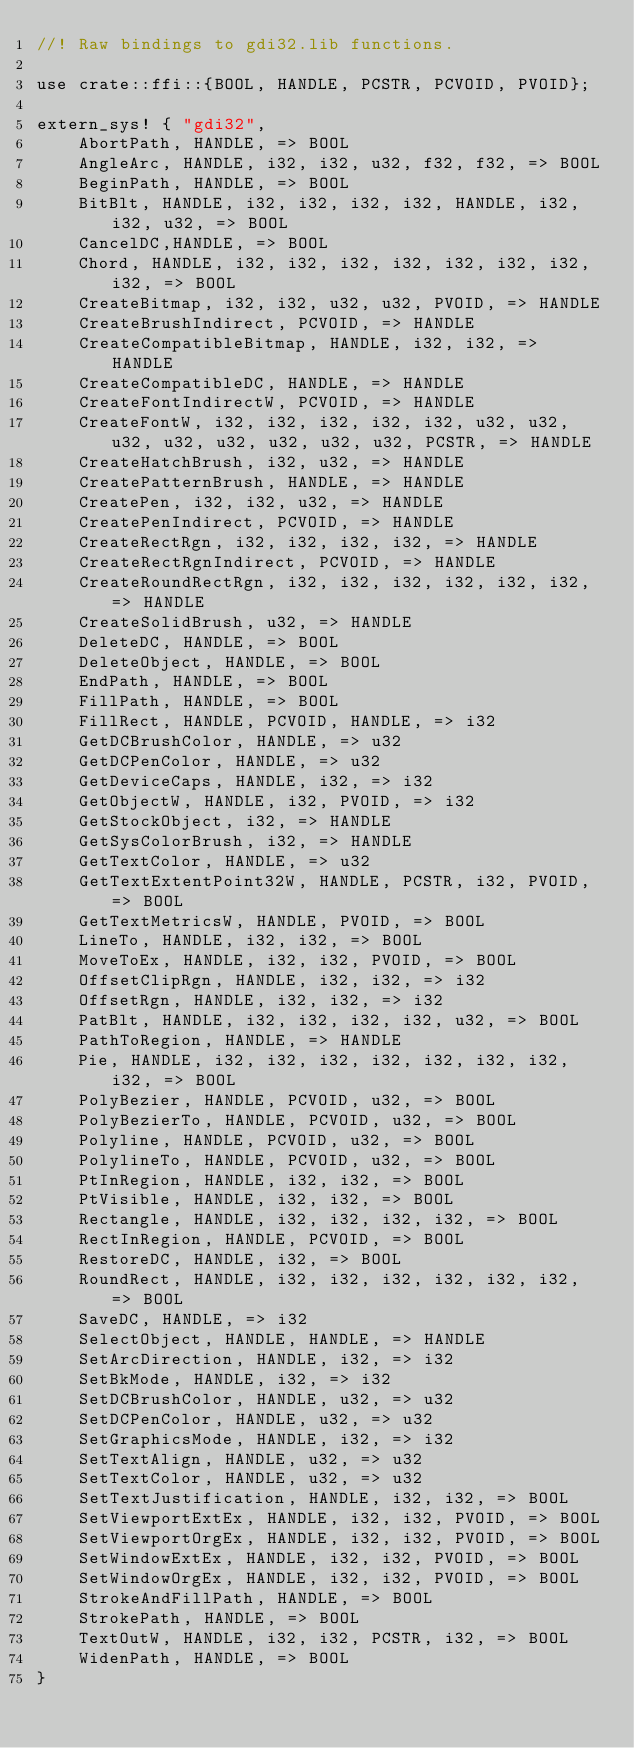Convert code to text. <code><loc_0><loc_0><loc_500><loc_500><_Rust_>//! Raw bindings to gdi32.lib functions.

use crate::ffi::{BOOL, HANDLE, PCSTR, PCVOID, PVOID};

extern_sys! { "gdi32",
	AbortPath, HANDLE, => BOOL
	AngleArc, HANDLE, i32, i32, u32, f32, f32, => BOOL
	BeginPath, HANDLE, => BOOL
	BitBlt, HANDLE, i32, i32, i32, i32, HANDLE, i32, i32, u32, => BOOL
	CancelDC,HANDLE, => BOOL
	Chord, HANDLE, i32, i32, i32, i32, i32, i32, i32, i32, => BOOL
	CreateBitmap, i32, i32, u32, u32, PVOID, => HANDLE
	CreateBrushIndirect, PCVOID, => HANDLE
	CreateCompatibleBitmap, HANDLE, i32, i32, => HANDLE
	CreateCompatibleDC, HANDLE, => HANDLE
	CreateFontIndirectW, PCVOID, => HANDLE
	CreateFontW, i32, i32, i32, i32, i32, u32, u32, u32, u32, u32, u32, u32, u32, PCSTR, => HANDLE
	CreateHatchBrush, i32, u32, => HANDLE
	CreatePatternBrush, HANDLE, => HANDLE
	CreatePen, i32, i32, u32, => HANDLE
	CreatePenIndirect, PCVOID, => HANDLE
	CreateRectRgn, i32, i32, i32, i32, => HANDLE
	CreateRectRgnIndirect, PCVOID, => HANDLE
	CreateRoundRectRgn, i32, i32, i32, i32, i32, i32, => HANDLE
	CreateSolidBrush, u32, => HANDLE
	DeleteDC, HANDLE, => BOOL
	DeleteObject, HANDLE, => BOOL
	EndPath, HANDLE, => BOOL
	FillPath, HANDLE, => BOOL
	FillRect, HANDLE, PCVOID, HANDLE, => i32
	GetDCBrushColor, HANDLE, => u32
	GetDCPenColor, HANDLE, => u32
	GetDeviceCaps, HANDLE, i32, => i32
	GetObjectW, HANDLE, i32, PVOID, => i32
	GetStockObject, i32, => HANDLE
	GetSysColorBrush, i32, => HANDLE
	GetTextColor, HANDLE, => u32
	GetTextExtentPoint32W, HANDLE, PCSTR, i32, PVOID, => BOOL
	GetTextMetricsW, HANDLE, PVOID, => BOOL
	LineTo, HANDLE, i32, i32, => BOOL
	MoveToEx, HANDLE, i32, i32, PVOID, => BOOL
	OffsetClipRgn, HANDLE, i32, i32, => i32
	OffsetRgn, HANDLE, i32, i32, => i32
	PatBlt, HANDLE, i32, i32, i32, i32, u32, => BOOL
	PathToRegion, HANDLE, => HANDLE
	Pie, HANDLE, i32, i32, i32, i32, i32, i32, i32, i32, => BOOL
	PolyBezier, HANDLE, PCVOID, u32, => BOOL
	PolyBezierTo, HANDLE, PCVOID, u32, => BOOL
	Polyline, HANDLE, PCVOID, u32, => BOOL
	PolylineTo, HANDLE, PCVOID, u32, => BOOL
	PtInRegion, HANDLE, i32, i32, => BOOL
	PtVisible, HANDLE, i32, i32, => BOOL
	Rectangle, HANDLE, i32, i32, i32, i32, => BOOL
	RectInRegion, HANDLE, PCVOID, => BOOL
	RestoreDC, HANDLE, i32, => BOOL
	RoundRect, HANDLE, i32, i32, i32, i32, i32, i32, => BOOL
	SaveDC, HANDLE, => i32
	SelectObject, HANDLE, HANDLE, => HANDLE
	SetArcDirection, HANDLE, i32, => i32
	SetBkMode, HANDLE, i32, => i32
	SetDCBrushColor, HANDLE, u32, => u32
	SetDCPenColor, HANDLE, u32, => u32
	SetGraphicsMode, HANDLE, i32, => i32
	SetTextAlign, HANDLE, u32, => u32
	SetTextColor, HANDLE, u32, => u32
	SetTextJustification, HANDLE, i32, i32, => BOOL
	SetViewportExtEx, HANDLE, i32, i32, PVOID, => BOOL
	SetViewportOrgEx, HANDLE, i32, i32, PVOID, => BOOL
	SetWindowExtEx, HANDLE, i32, i32, PVOID, => BOOL
	SetWindowOrgEx, HANDLE, i32, i32, PVOID, => BOOL
	StrokeAndFillPath, HANDLE, => BOOL
	StrokePath, HANDLE, => BOOL
	TextOutW, HANDLE, i32, i32, PCSTR, i32, => BOOL
	WidenPath, HANDLE, => BOOL
}
</code> 